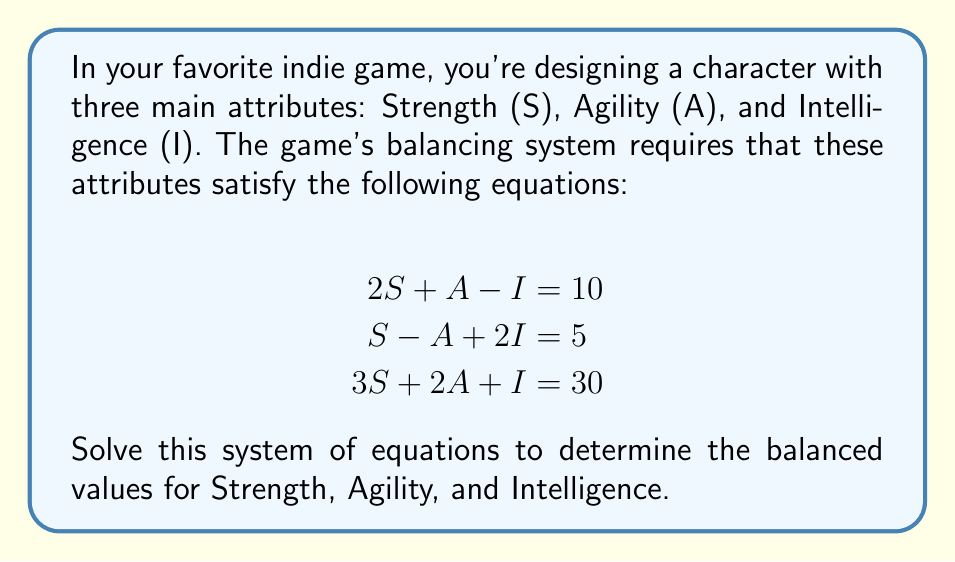Solve this math problem. Let's solve this system of equations using the elimination method:

1) First, let's eliminate A by adding equation (1) and equation (2):

   $$(2S + A - I = 10) + (S - A + 2I = 5)$$
   $$3S + I = 15 \quad \text{(4)}$$

2) Now, let's eliminate S by subtracting 3 times equation (4) from equation (3):

   $$(3S + 2A + I = 30) - 3(3S + I = 15)$$
   $$3S + 2A + I - 9S - 3I = 30 - 45$$
   $$2A - 6S - 2I = -15$$
   $$2A - 2(3S + I) = -15$$
   $$2A - 2(15) = -15 \quad \text{(using equation (4))}$$
   $$2A - 30 = -15$$
   $$2A = 15$$
   $$A = 7.5$$

3) Now that we know A, we can substitute it into equation (4) to find S:

   $$3S + I = 15$$
   $$3S + (2S + A - 10) = 15 \quad \text{(using equation (1))}$$
   $$3S + (2S + 7.5 - 10) = 15$$
   $$5S - 2.5 = 15$$
   $$5S = 17.5$$
   $$S = 3.5$$

4) Finally, we can find I using equation (1):

   $$2S + A - I = 10$$
   $$2(3.5) + 7.5 - I = 10$$
   $$7 + 7.5 - I = 10$$
   $$14.5 - I = 10$$
   $$-I = -4.5$$
   $$I = 4.5$$

5) Let's verify our solution in the third equation:

   $$3S + 2A + I = 30$$
   $$3(3.5) + 2(7.5) + 4.5 = 30$$
   $$10.5 + 15 + 4.5 = 30$$
   $$30 = 30 \quad \text{(verified)}$$
Answer: The balanced attributes are:
Strength (S) = 3.5
Agility (A) = 7.5
Intelligence (I) = 4.5 